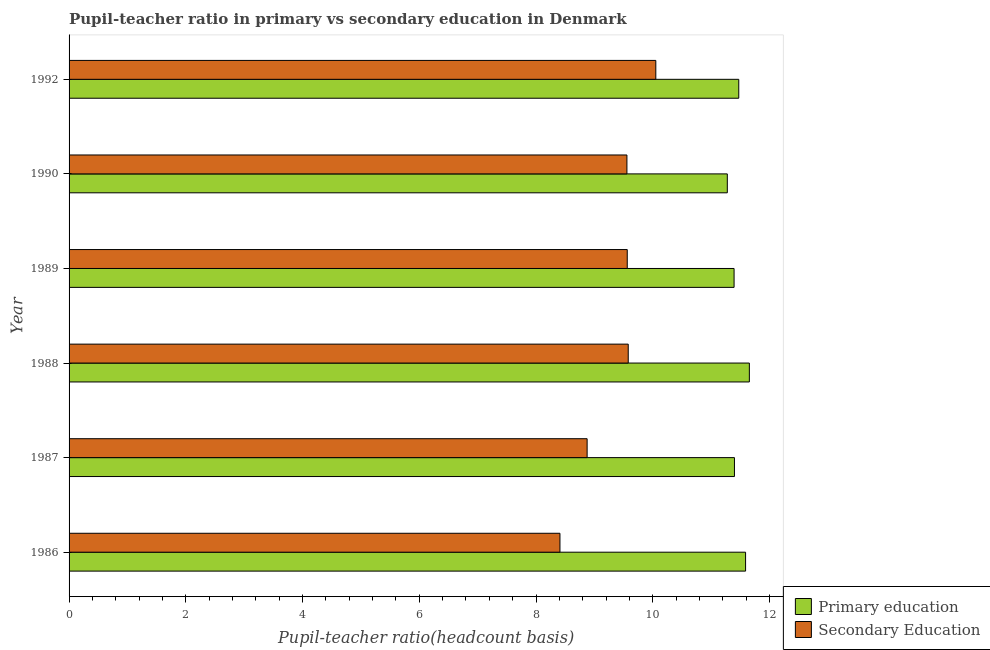How many different coloured bars are there?
Offer a terse response. 2. How many groups of bars are there?
Make the answer very short. 6. Are the number of bars on each tick of the Y-axis equal?
Provide a short and direct response. Yes. How many bars are there on the 4th tick from the top?
Make the answer very short. 2. How many bars are there on the 1st tick from the bottom?
Keep it short and to the point. 2. In how many cases, is the number of bars for a given year not equal to the number of legend labels?
Provide a succinct answer. 0. What is the pupil teacher ratio on secondary education in 1992?
Make the answer very short. 10.05. Across all years, what is the maximum pupil teacher ratio on secondary education?
Ensure brevity in your answer.  10.05. Across all years, what is the minimum pupil teacher ratio on secondary education?
Give a very brief answer. 8.41. In which year was the pupil-teacher ratio in primary education maximum?
Provide a succinct answer. 1988. What is the total pupil-teacher ratio in primary education in the graph?
Your response must be concise. 68.79. What is the difference between the pupil teacher ratio on secondary education in 1988 and that in 1989?
Provide a succinct answer. 0.02. What is the difference between the pupil teacher ratio on secondary education in 1989 and the pupil-teacher ratio in primary education in 1990?
Your response must be concise. -1.71. What is the average pupil-teacher ratio in primary education per year?
Ensure brevity in your answer.  11.46. In the year 1988, what is the difference between the pupil-teacher ratio in primary education and pupil teacher ratio on secondary education?
Offer a very short reply. 2.08. What is the ratio of the pupil teacher ratio on secondary education in 1986 to that in 1988?
Provide a succinct answer. 0.88. Is the pupil-teacher ratio in primary education in 1987 less than that in 1989?
Offer a terse response. No. What is the difference between the highest and the second highest pupil-teacher ratio in primary education?
Your answer should be very brief. 0.07. What is the difference between the highest and the lowest pupil teacher ratio on secondary education?
Make the answer very short. 1.64. What does the 1st bar from the top in 1989 represents?
Give a very brief answer. Secondary Education. What does the 1st bar from the bottom in 1987 represents?
Make the answer very short. Primary education. How many bars are there?
Offer a very short reply. 12. Are all the bars in the graph horizontal?
Keep it short and to the point. Yes. What is the difference between two consecutive major ticks on the X-axis?
Make the answer very short. 2. Does the graph contain any zero values?
Ensure brevity in your answer.  No. Does the graph contain grids?
Ensure brevity in your answer.  No. What is the title of the graph?
Give a very brief answer. Pupil-teacher ratio in primary vs secondary education in Denmark. Does "UN agencies" appear as one of the legend labels in the graph?
Give a very brief answer. No. What is the label or title of the X-axis?
Provide a short and direct response. Pupil-teacher ratio(headcount basis). What is the Pupil-teacher ratio(headcount basis) of Primary education in 1986?
Provide a short and direct response. 11.59. What is the Pupil-teacher ratio(headcount basis) in Secondary Education in 1986?
Your response must be concise. 8.41. What is the Pupil-teacher ratio(headcount basis) of Primary education in 1987?
Make the answer very short. 11.4. What is the Pupil-teacher ratio(headcount basis) of Secondary Education in 1987?
Provide a succinct answer. 8.88. What is the Pupil-teacher ratio(headcount basis) in Primary education in 1988?
Provide a short and direct response. 11.66. What is the Pupil-teacher ratio(headcount basis) in Secondary Education in 1988?
Offer a very short reply. 9.58. What is the Pupil-teacher ratio(headcount basis) in Primary education in 1989?
Your answer should be very brief. 11.39. What is the Pupil-teacher ratio(headcount basis) of Secondary Education in 1989?
Offer a terse response. 9.56. What is the Pupil-teacher ratio(headcount basis) of Primary education in 1990?
Offer a very short reply. 11.28. What is the Pupil-teacher ratio(headcount basis) in Secondary Education in 1990?
Make the answer very short. 9.56. What is the Pupil-teacher ratio(headcount basis) in Primary education in 1992?
Your answer should be compact. 11.47. What is the Pupil-teacher ratio(headcount basis) of Secondary Education in 1992?
Your answer should be compact. 10.05. Across all years, what is the maximum Pupil-teacher ratio(headcount basis) of Primary education?
Provide a short and direct response. 11.66. Across all years, what is the maximum Pupil-teacher ratio(headcount basis) in Secondary Education?
Your answer should be very brief. 10.05. Across all years, what is the minimum Pupil-teacher ratio(headcount basis) of Primary education?
Offer a terse response. 11.28. Across all years, what is the minimum Pupil-teacher ratio(headcount basis) of Secondary Education?
Your response must be concise. 8.41. What is the total Pupil-teacher ratio(headcount basis) in Primary education in the graph?
Keep it short and to the point. 68.79. What is the total Pupil-teacher ratio(headcount basis) in Secondary Education in the graph?
Give a very brief answer. 56.04. What is the difference between the Pupil-teacher ratio(headcount basis) in Primary education in 1986 and that in 1987?
Provide a short and direct response. 0.19. What is the difference between the Pupil-teacher ratio(headcount basis) in Secondary Education in 1986 and that in 1987?
Give a very brief answer. -0.47. What is the difference between the Pupil-teacher ratio(headcount basis) of Primary education in 1986 and that in 1988?
Offer a terse response. -0.06. What is the difference between the Pupil-teacher ratio(headcount basis) of Secondary Education in 1986 and that in 1988?
Offer a terse response. -1.17. What is the difference between the Pupil-teacher ratio(headcount basis) in Primary education in 1986 and that in 1989?
Your answer should be very brief. 0.2. What is the difference between the Pupil-teacher ratio(headcount basis) of Secondary Education in 1986 and that in 1989?
Make the answer very short. -1.15. What is the difference between the Pupil-teacher ratio(headcount basis) in Primary education in 1986 and that in 1990?
Offer a very short reply. 0.31. What is the difference between the Pupil-teacher ratio(headcount basis) of Secondary Education in 1986 and that in 1990?
Make the answer very short. -1.15. What is the difference between the Pupil-teacher ratio(headcount basis) of Primary education in 1986 and that in 1992?
Make the answer very short. 0.12. What is the difference between the Pupil-teacher ratio(headcount basis) of Secondary Education in 1986 and that in 1992?
Your answer should be compact. -1.64. What is the difference between the Pupil-teacher ratio(headcount basis) in Primary education in 1987 and that in 1988?
Your answer should be compact. -0.26. What is the difference between the Pupil-teacher ratio(headcount basis) in Secondary Education in 1987 and that in 1988?
Your response must be concise. -0.7. What is the difference between the Pupil-teacher ratio(headcount basis) in Primary education in 1987 and that in 1989?
Give a very brief answer. 0.01. What is the difference between the Pupil-teacher ratio(headcount basis) in Secondary Education in 1987 and that in 1989?
Keep it short and to the point. -0.69. What is the difference between the Pupil-teacher ratio(headcount basis) in Primary education in 1987 and that in 1990?
Make the answer very short. 0.12. What is the difference between the Pupil-teacher ratio(headcount basis) in Secondary Education in 1987 and that in 1990?
Provide a succinct answer. -0.68. What is the difference between the Pupil-teacher ratio(headcount basis) of Primary education in 1987 and that in 1992?
Ensure brevity in your answer.  -0.07. What is the difference between the Pupil-teacher ratio(headcount basis) in Secondary Education in 1987 and that in 1992?
Ensure brevity in your answer.  -1.18. What is the difference between the Pupil-teacher ratio(headcount basis) of Primary education in 1988 and that in 1989?
Keep it short and to the point. 0.26. What is the difference between the Pupil-teacher ratio(headcount basis) of Secondary Education in 1988 and that in 1989?
Keep it short and to the point. 0.02. What is the difference between the Pupil-teacher ratio(headcount basis) in Primary education in 1988 and that in 1990?
Provide a short and direct response. 0.38. What is the difference between the Pupil-teacher ratio(headcount basis) of Secondary Education in 1988 and that in 1990?
Keep it short and to the point. 0.02. What is the difference between the Pupil-teacher ratio(headcount basis) in Primary education in 1988 and that in 1992?
Provide a short and direct response. 0.18. What is the difference between the Pupil-teacher ratio(headcount basis) of Secondary Education in 1988 and that in 1992?
Your response must be concise. -0.47. What is the difference between the Pupil-teacher ratio(headcount basis) in Primary education in 1989 and that in 1990?
Make the answer very short. 0.12. What is the difference between the Pupil-teacher ratio(headcount basis) of Secondary Education in 1989 and that in 1990?
Your response must be concise. 0.01. What is the difference between the Pupil-teacher ratio(headcount basis) in Primary education in 1989 and that in 1992?
Keep it short and to the point. -0.08. What is the difference between the Pupil-teacher ratio(headcount basis) of Secondary Education in 1989 and that in 1992?
Your answer should be very brief. -0.49. What is the difference between the Pupil-teacher ratio(headcount basis) of Primary education in 1990 and that in 1992?
Make the answer very short. -0.2. What is the difference between the Pupil-teacher ratio(headcount basis) in Secondary Education in 1990 and that in 1992?
Provide a succinct answer. -0.49. What is the difference between the Pupil-teacher ratio(headcount basis) in Primary education in 1986 and the Pupil-teacher ratio(headcount basis) in Secondary Education in 1987?
Your response must be concise. 2.71. What is the difference between the Pupil-teacher ratio(headcount basis) of Primary education in 1986 and the Pupil-teacher ratio(headcount basis) of Secondary Education in 1988?
Provide a succinct answer. 2.01. What is the difference between the Pupil-teacher ratio(headcount basis) of Primary education in 1986 and the Pupil-teacher ratio(headcount basis) of Secondary Education in 1989?
Your answer should be very brief. 2.03. What is the difference between the Pupil-teacher ratio(headcount basis) of Primary education in 1986 and the Pupil-teacher ratio(headcount basis) of Secondary Education in 1990?
Your answer should be compact. 2.03. What is the difference between the Pupil-teacher ratio(headcount basis) in Primary education in 1986 and the Pupil-teacher ratio(headcount basis) in Secondary Education in 1992?
Offer a terse response. 1.54. What is the difference between the Pupil-teacher ratio(headcount basis) in Primary education in 1987 and the Pupil-teacher ratio(headcount basis) in Secondary Education in 1988?
Offer a terse response. 1.82. What is the difference between the Pupil-teacher ratio(headcount basis) in Primary education in 1987 and the Pupil-teacher ratio(headcount basis) in Secondary Education in 1989?
Your answer should be very brief. 1.84. What is the difference between the Pupil-teacher ratio(headcount basis) in Primary education in 1987 and the Pupil-teacher ratio(headcount basis) in Secondary Education in 1990?
Keep it short and to the point. 1.84. What is the difference between the Pupil-teacher ratio(headcount basis) of Primary education in 1987 and the Pupil-teacher ratio(headcount basis) of Secondary Education in 1992?
Offer a very short reply. 1.35. What is the difference between the Pupil-teacher ratio(headcount basis) in Primary education in 1988 and the Pupil-teacher ratio(headcount basis) in Secondary Education in 1989?
Provide a succinct answer. 2.09. What is the difference between the Pupil-teacher ratio(headcount basis) of Primary education in 1988 and the Pupil-teacher ratio(headcount basis) of Secondary Education in 1990?
Offer a terse response. 2.1. What is the difference between the Pupil-teacher ratio(headcount basis) in Primary education in 1988 and the Pupil-teacher ratio(headcount basis) in Secondary Education in 1992?
Ensure brevity in your answer.  1.6. What is the difference between the Pupil-teacher ratio(headcount basis) in Primary education in 1989 and the Pupil-teacher ratio(headcount basis) in Secondary Education in 1990?
Your answer should be compact. 1.84. What is the difference between the Pupil-teacher ratio(headcount basis) in Primary education in 1989 and the Pupil-teacher ratio(headcount basis) in Secondary Education in 1992?
Give a very brief answer. 1.34. What is the difference between the Pupil-teacher ratio(headcount basis) in Primary education in 1990 and the Pupil-teacher ratio(headcount basis) in Secondary Education in 1992?
Keep it short and to the point. 1.23. What is the average Pupil-teacher ratio(headcount basis) in Primary education per year?
Your answer should be very brief. 11.47. What is the average Pupil-teacher ratio(headcount basis) in Secondary Education per year?
Ensure brevity in your answer.  9.34. In the year 1986, what is the difference between the Pupil-teacher ratio(headcount basis) of Primary education and Pupil-teacher ratio(headcount basis) of Secondary Education?
Your answer should be compact. 3.18. In the year 1987, what is the difference between the Pupil-teacher ratio(headcount basis) in Primary education and Pupil-teacher ratio(headcount basis) in Secondary Education?
Your response must be concise. 2.52. In the year 1988, what is the difference between the Pupil-teacher ratio(headcount basis) in Primary education and Pupil-teacher ratio(headcount basis) in Secondary Education?
Provide a succinct answer. 2.08. In the year 1989, what is the difference between the Pupil-teacher ratio(headcount basis) of Primary education and Pupil-teacher ratio(headcount basis) of Secondary Education?
Your answer should be very brief. 1.83. In the year 1990, what is the difference between the Pupil-teacher ratio(headcount basis) of Primary education and Pupil-teacher ratio(headcount basis) of Secondary Education?
Ensure brevity in your answer.  1.72. In the year 1992, what is the difference between the Pupil-teacher ratio(headcount basis) in Primary education and Pupil-teacher ratio(headcount basis) in Secondary Education?
Offer a terse response. 1.42. What is the ratio of the Pupil-teacher ratio(headcount basis) of Primary education in 1986 to that in 1987?
Provide a succinct answer. 1.02. What is the ratio of the Pupil-teacher ratio(headcount basis) in Secondary Education in 1986 to that in 1987?
Your answer should be very brief. 0.95. What is the ratio of the Pupil-teacher ratio(headcount basis) in Primary education in 1986 to that in 1988?
Give a very brief answer. 0.99. What is the ratio of the Pupil-teacher ratio(headcount basis) in Secondary Education in 1986 to that in 1988?
Offer a terse response. 0.88. What is the ratio of the Pupil-teacher ratio(headcount basis) of Primary education in 1986 to that in 1989?
Ensure brevity in your answer.  1.02. What is the ratio of the Pupil-teacher ratio(headcount basis) in Secondary Education in 1986 to that in 1989?
Your answer should be very brief. 0.88. What is the ratio of the Pupil-teacher ratio(headcount basis) of Primary education in 1986 to that in 1990?
Give a very brief answer. 1.03. What is the ratio of the Pupil-teacher ratio(headcount basis) in Primary education in 1986 to that in 1992?
Keep it short and to the point. 1.01. What is the ratio of the Pupil-teacher ratio(headcount basis) of Secondary Education in 1986 to that in 1992?
Your response must be concise. 0.84. What is the ratio of the Pupil-teacher ratio(headcount basis) in Primary education in 1987 to that in 1988?
Provide a short and direct response. 0.98. What is the ratio of the Pupil-teacher ratio(headcount basis) in Secondary Education in 1987 to that in 1988?
Offer a very short reply. 0.93. What is the ratio of the Pupil-teacher ratio(headcount basis) in Primary education in 1987 to that in 1989?
Offer a terse response. 1. What is the ratio of the Pupil-teacher ratio(headcount basis) of Secondary Education in 1987 to that in 1989?
Offer a terse response. 0.93. What is the ratio of the Pupil-teacher ratio(headcount basis) of Primary education in 1987 to that in 1990?
Keep it short and to the point. 1.01. What is the ratio of the Pupil-teacher ratio(headcount basis) in Secondary Education in 1987 to that in 1990?
Give a very brief answer. 0.93. What is the ratio of the Pupil-teacher ratio(headcount basis) in Secondary Education in 1987 to that in 1992?
Keep it short and to the point. 0.88. What is the ratio of the Pupil-teacher ratio(headcount basis) in Primary education in 1988 to that in 1989?
Ensure brevity in your answer.  1.02. What is the ratio of the Pupil-teacher ratio(headcount basis) of Secondary Education in 1988 to that in 1989?
Your answer should be very brief. 1. What is the ratio of the Pupil-teacher ratio(headcount basis) of Primary education in 1988 to that in 1990?
Your response must be concise. 1.03. What is the ratio of the Pupil-teacher ratio(headcount basis) of Primary education in 1988 to that in 1992?
Your response must be concise. 1.02. What is the ratio of the Pupil-teacher ratio(headcount basis) of Secondary Education in 1988 to that in 1992?
Your response must be concise. 0.95. What is the ratio of the Pupil-teacher ratio(headcount basis) of Primary education in 1989 to that in 1990?
Offer a terse response. 1.01. What is the ratio of the Pupil-teacher ratio(headcount basis) of Secondary Education in 1989 to that in 1990?
Provide a succinct answer. 1. What is the ratio of the Pupil-teacher ratio(headcount basis) in Secondary Education in 1989 to that in 1992?
Provide a short and direct response. 0.95. What is the ratio of the Pupil-teacher ratio(headcount basis) in Primary education in 1990 to that in 1992?
Keep it short and to the point. 0.98. What is the ratio of the Pupil-teacher ratio(headcount basis) in Secondary Education in 1990 to that in 1992?
Give a very brief answer. 0.95. What is the difference between the highest and the second highest Pupil-teacher ratio(headcount basis) of Primary education?
Your answer should be compact. 0.06. What is the difference between the highest and the second highest Pupil-teacher ratio(headcount basis) of Secondary Education?
Offer a terse response. 0.47. What is the difference between the highest and the lowest Pupil-teacher ratio(headcount basis) in Primary education?
Your response must be concise. 0.38. What is the difference between the highest and the lowest Pupil-teacher ratio(headcount basis) of Secondary Education?
Your answer should be very brief. 1.64. 